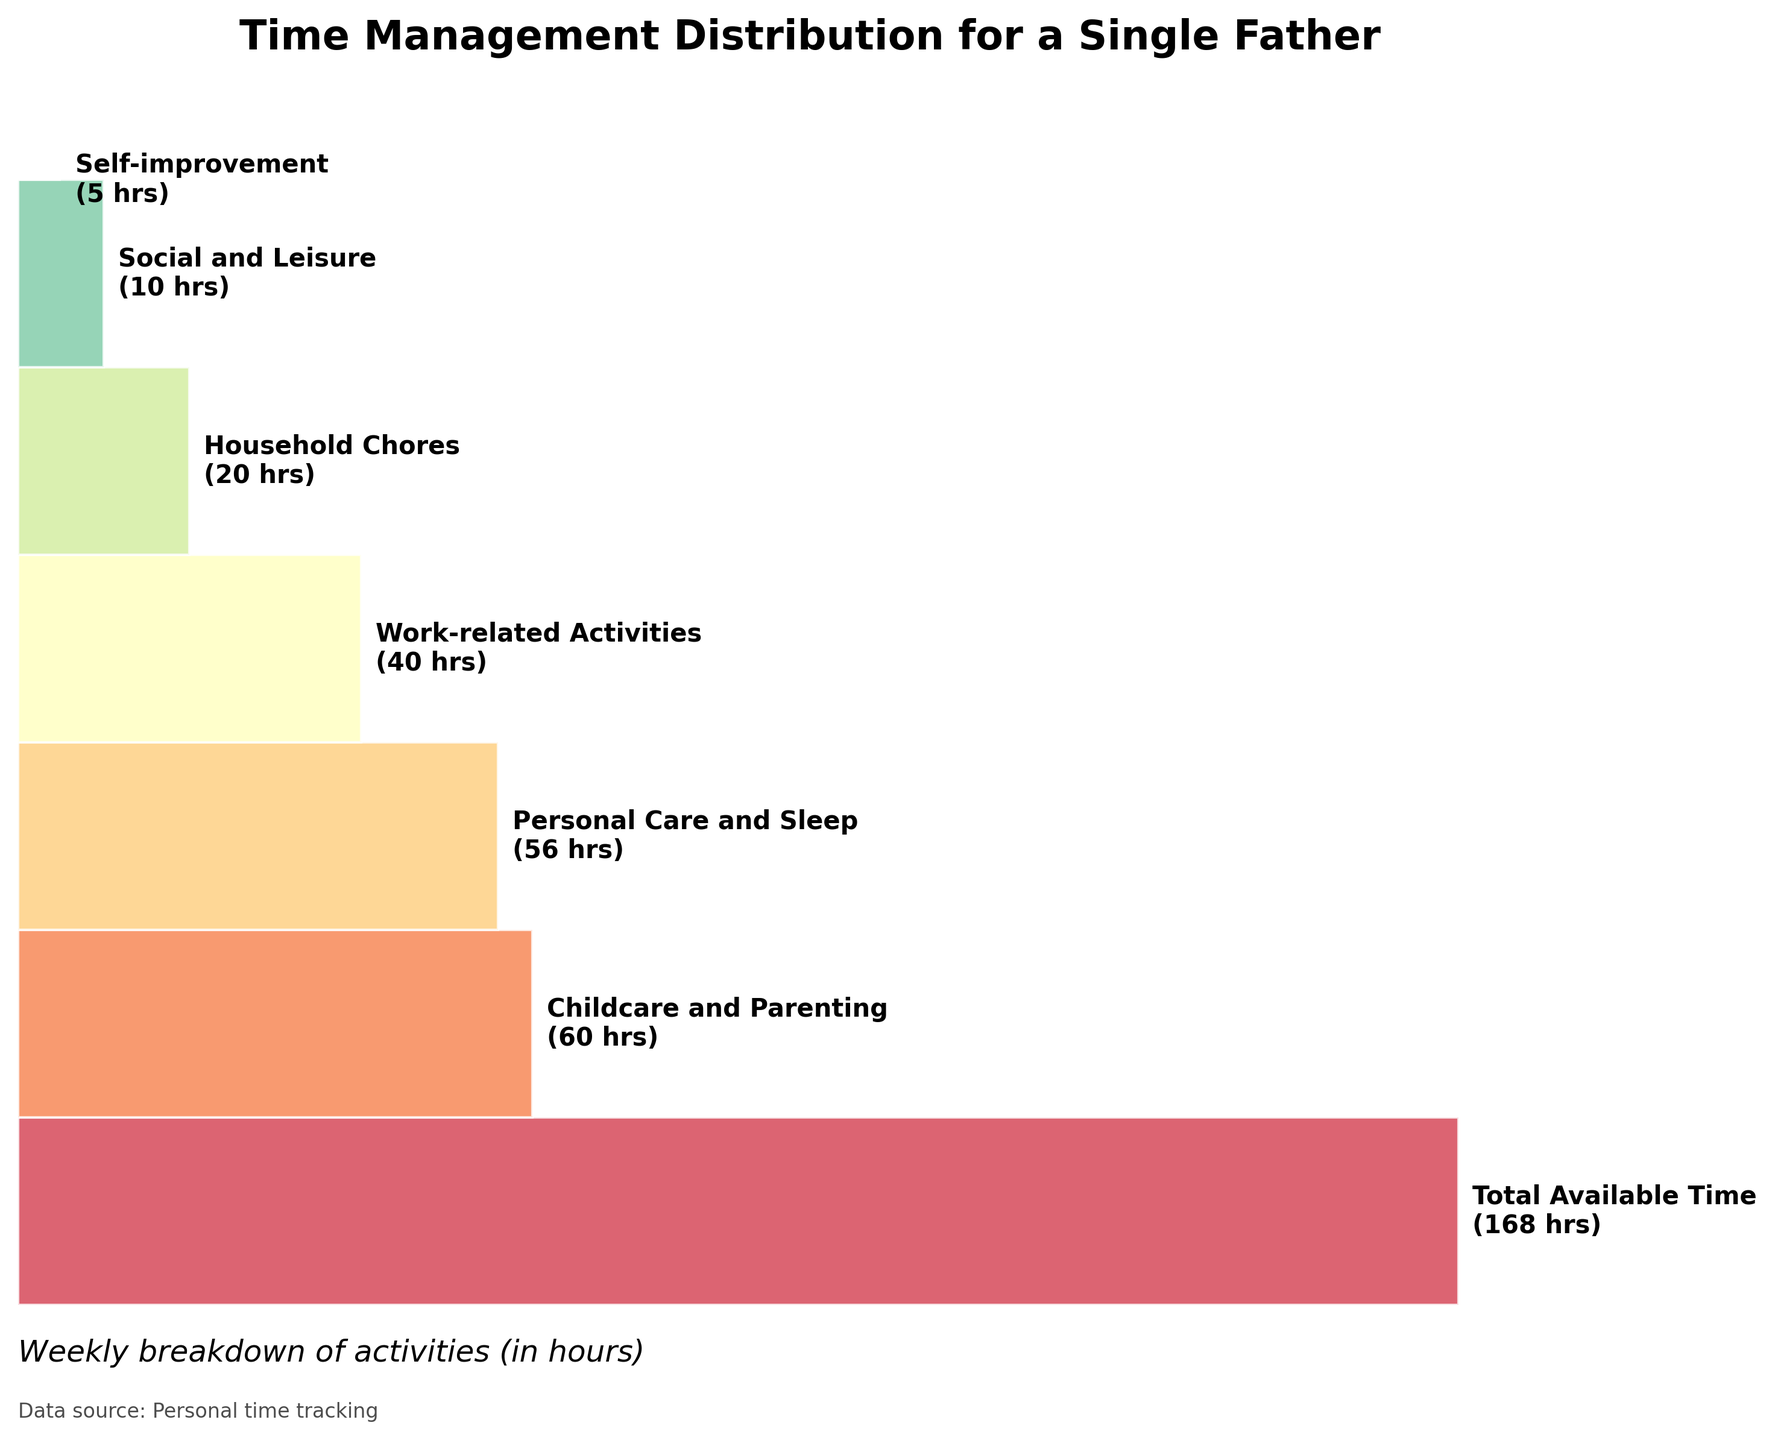What is the title of the chart? The title can be found at the top of the chart. It is a clear description of what the chart represents.
Answer: Time Management Distribution for a Single Father How many categories are displayed in the funnel chart? By counting the number of labels/texts on the chart, we can find the number of distinct categories included in the visualization.
Answer: 6 Which category takes up the most hours per week? By observing the width of the funnel sections and the labels, we can see which category has the widest section representing the highest number of hours.
Answer: Childcare and Parenting What is the total weekly time spent on personal care and sleep combined with social and leisure activities? Adding the hours for "Personal Care and Sleep" and "Social and Leisure", we can get the total time spent on these activities.
Answer: 56 + 10 = 66 hours Which category occupies the smallest portion of the funnel chart? By looking at the narrowest section in the chart and checking its label, we can determine which category is the smallest.
Answer: Self-improvement How does the time spent on work-related activities compare to the time spent on household chores? By comparing the hours stated for each of these categories, we can see the difference between them.
Answer: Work-related activities take 40 hours, whereas household chores take 20 hours; thus, work-related activities take twice as many hours as household chores What percentage of the total available time is spent on childcare and parenting? Dividing the hours spent on childcare and parenting by the total available time and then multiplying by 100 gives us the percentage.
Answer: (60 / 168) * 100 ≈ 35.7% What activities fall below 10 hours per week? By observing the chart, we can list activities with less than 10 hours based on their relative sizes and corresponding hours.
Answer: Self-improvement How much time is allocated to self-improvement compared to social and leisure activities? By comparing the hours mentioned for both categories, we calculate the difference or ratio between them.
Answer: Self-improvement takes 5 hours, whereas social and leisure take 10 hours; social and leisure activities take twice the time as self-improvement What is the total number of hours allocated to work-related activities, household chores, and self-improvement combined? Adding the hours for work-related activities, household chores, and self-improvement gives the total time spent on these activities.
Answer: 40 + 20 + 5 = 65 hours 